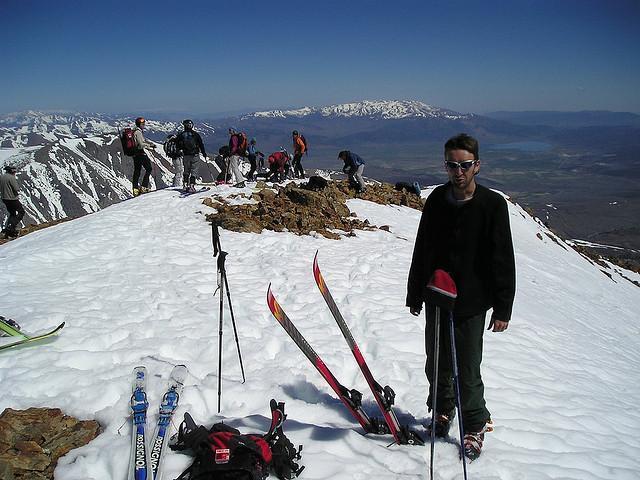How many ski are there?
Give a very brief answer. 2. How many fridges are in the picture?
Give a very brief answer. 0. 